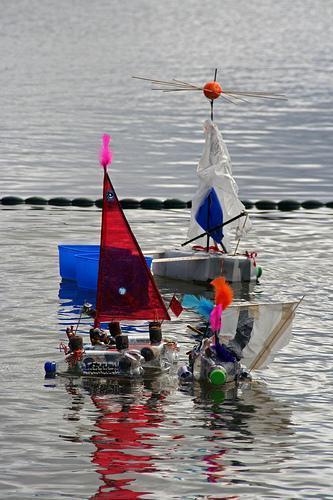How many handmade boats are pictured?
Give a very brief answer. 3. How many blue containers are attached the boat in the rear?
Give a very brief answer. 2. 